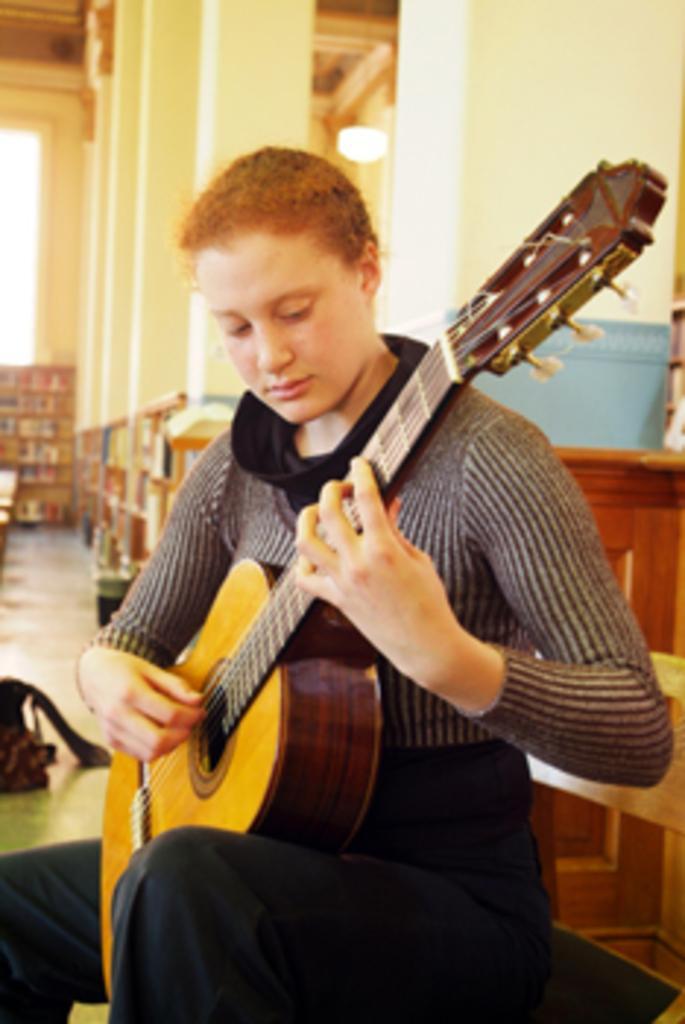In one or two sentences, can you explain what this image depicts? In the image we can see there is a person who is sitting and holding guitar in her hand. 